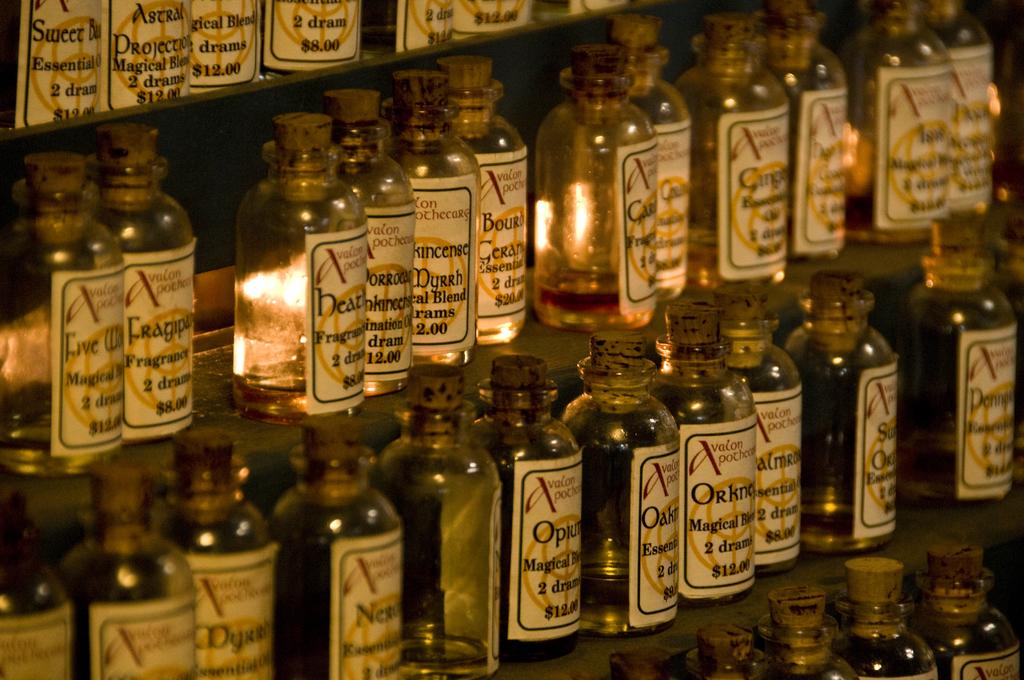How much does the second bottle at the top cost?
Offer a terse response. 12.00. 